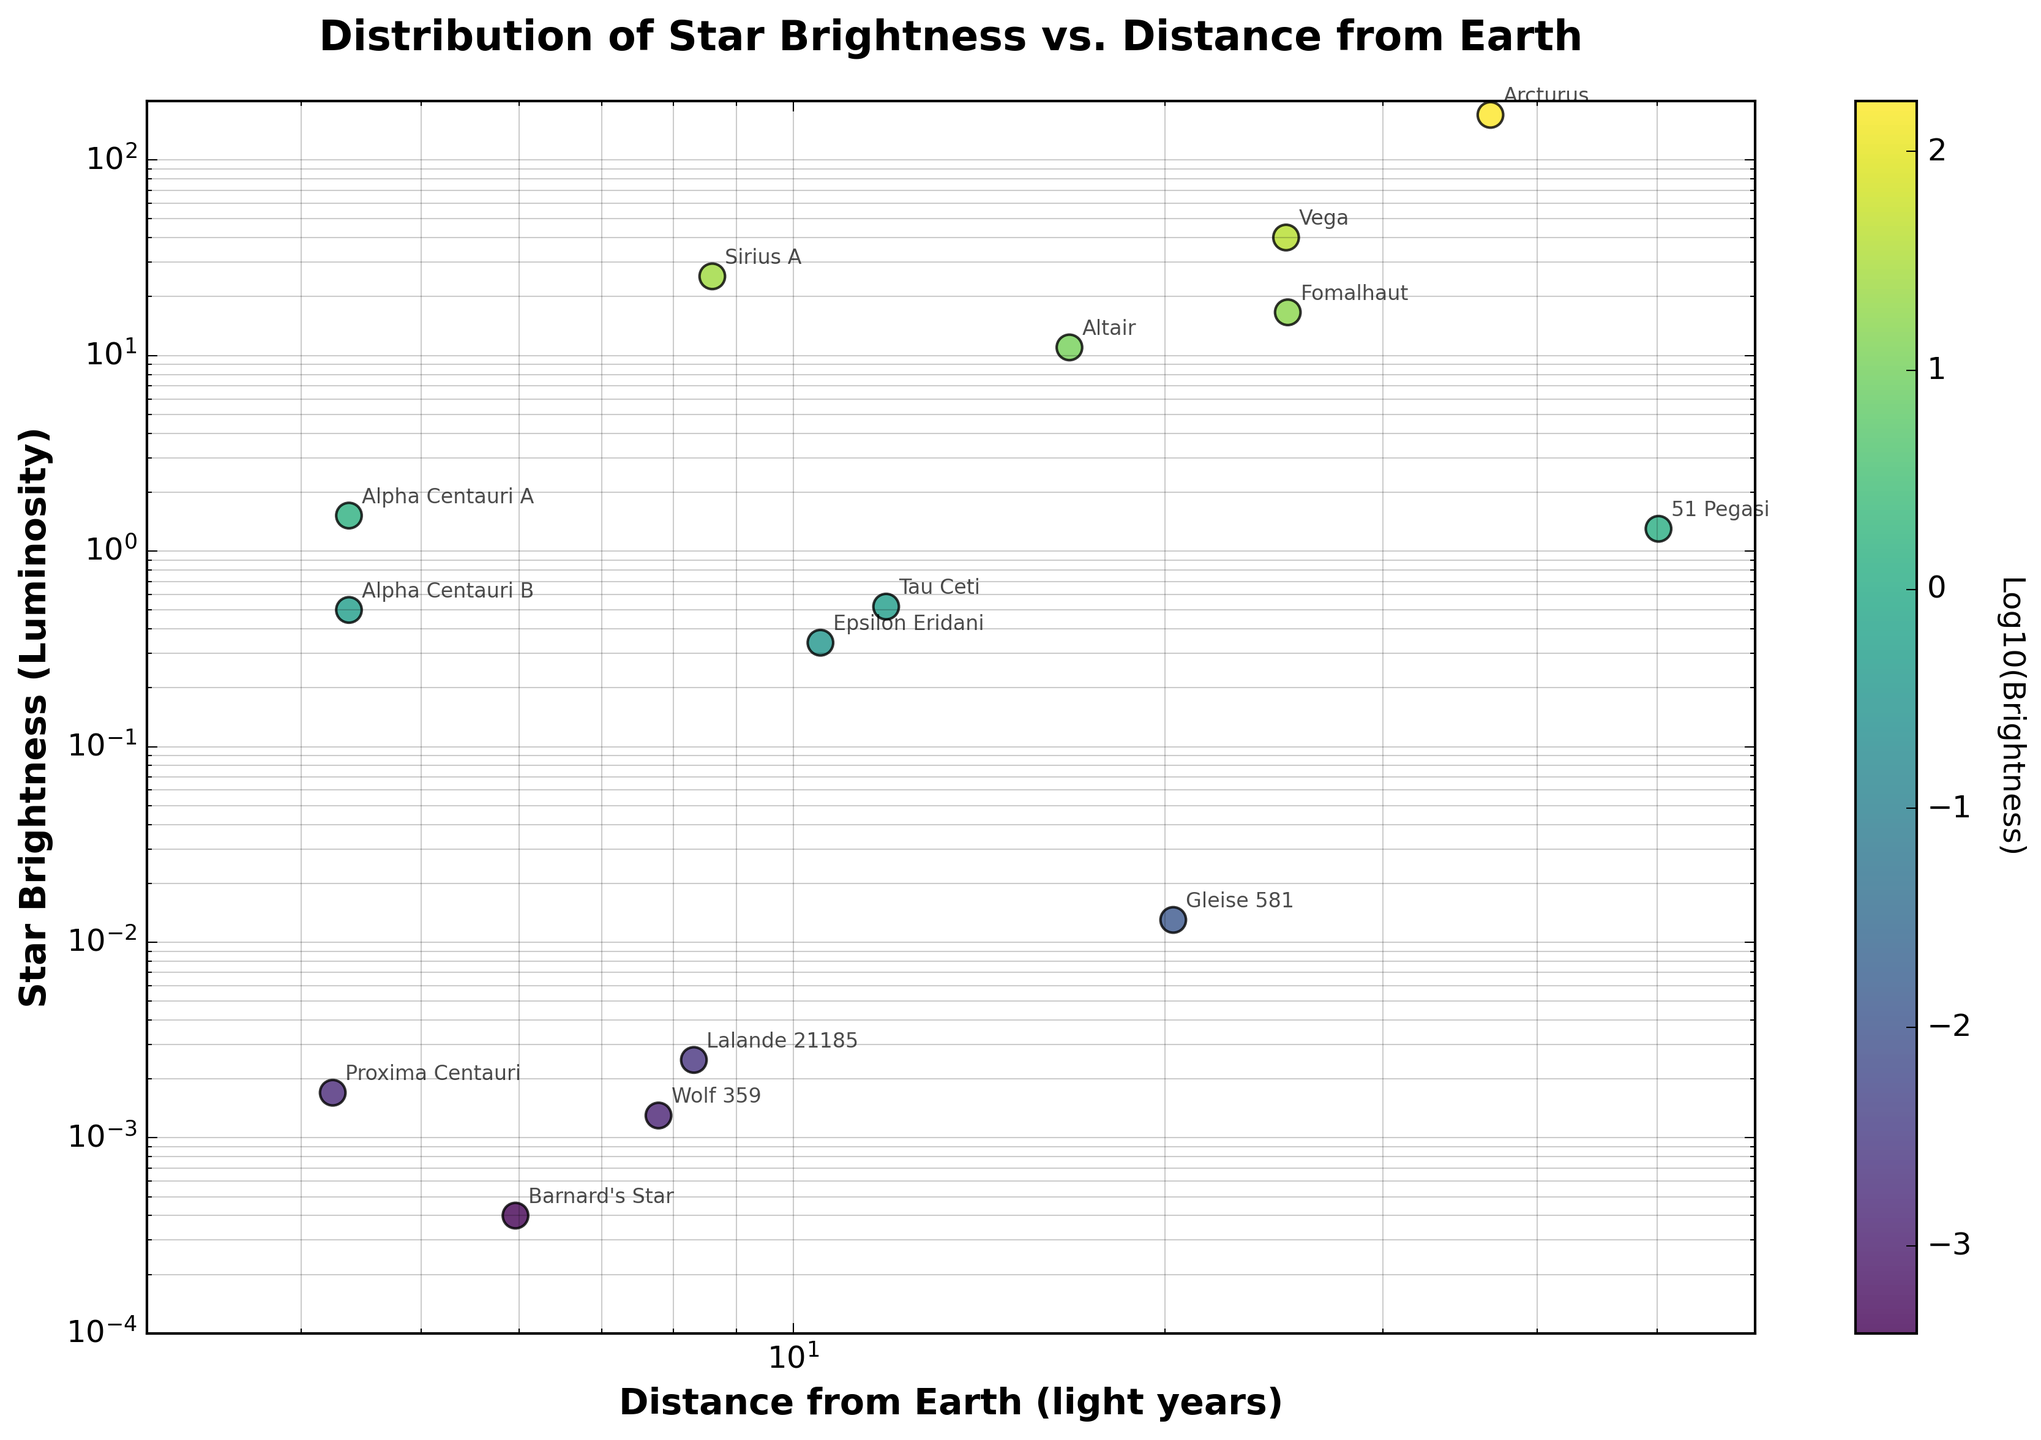What's the title of the figure? The title of the figure is usually placed at the top. In this case, it reads "Distribution of Star Brightness vs. Distance from Earth," which provides an overview of the data displayed.
Answer: Distribution of Star Brightness vs. Distance from Earth What are the labels of the x and y axes? The x and y axis labels are identified by looking for the text adjacent to the axes. Here, the x-axis is labeled "Distance from Earth (light years)" and the y-axis is labeled "Star Brightness (Luminosity)."
Answer: Distance from Earth (light years) and Star Brightness (Luminosity) How many data points are in the figure? Each data point represents a star, and if we count the stars listed, we find there are 15 of them in the figure.
Answer: 15 Which star is the farthest from Earth, and what is its brightness? We can identify the farthest star by examining the x-axis for the largest value, which corresponds to a distance of 50.14 light years (51 Pegasi). We then look vertically for its brightness, which is 1.3 luminosities.
Answer: 51 Pegasi, 1.3 luminosities What is unique about the color coding of the scatter plot? The scatter plot uses color coding to represent the logarithm of the brightness. This helps to visualize the relative brightness of stars more clearly, where darker colors represent lower brightness and lighter colors indicate higher brightness.
Answer: Color represents Log10(Brightness) Is there a star brighter than Sirius A? By comparing Sirius A’s brightness against other points on the y-axis, we find that no star appears above Sirius A's brightness of 25.4, indicating it is one of the brightest.
Answer: No Which star is nearest to Earth, and how bright is it? The nearest star can be identified by finding the point closest to the origin on the x-axis, which is Proxima Centauri at 4.24 light years. The vertical position of this point gives its brightness, which is 0.0017 luminosities.
Answer: Proxima Centauri, 0.0017 luminosities What is the relationship between distance from Earth and star brightness? Observing the scatter plot distribution, we see that most stars that are nearer tend to have lower brightness. However, there are exceptions like Sirius A. In general, there is no strict correlation as there are both dim and bright stars at various distances.
Answer: No strict correlation Which stars are annotated on the scatter plot moving vertically from the brightest to the dimmest star? By moving from the top of the plot downwards, stars are annotated as follows: Arcturus, Vega, Fomalhaut, Altair, Sirius A, 51 Pegasi, Alpha Centauri A, Tau Ceti, Epsilon Eridani, Alpha Centauri B, Lalande 21185, Gleise 581, Wolf 359, Proxima Centauri, and Barnard's Star.
Answer: Arcturus, Vega, Fomalhaut, Altair, Sirius A, 51 Pegasi, Alpha Centauri A, Tau Ceti, Epsilon Eridani, Alpha Centauri B, Lalande 21185, Gleise 581, Wolf 359, Proxima Centauri, Barnard's Star Compare the brightness of Alpha Centauri A to Alpha Centauri B. Alpha Centauri A is located on the plot slightly above Alpha Centauri B, indicating it is brighter. Specifically, Alpha Centauri A has a brightness of 1.519, whereas Alpha Centauri B has 0.500 luminosities.
Answer: Alpha Centauri A is brighter 